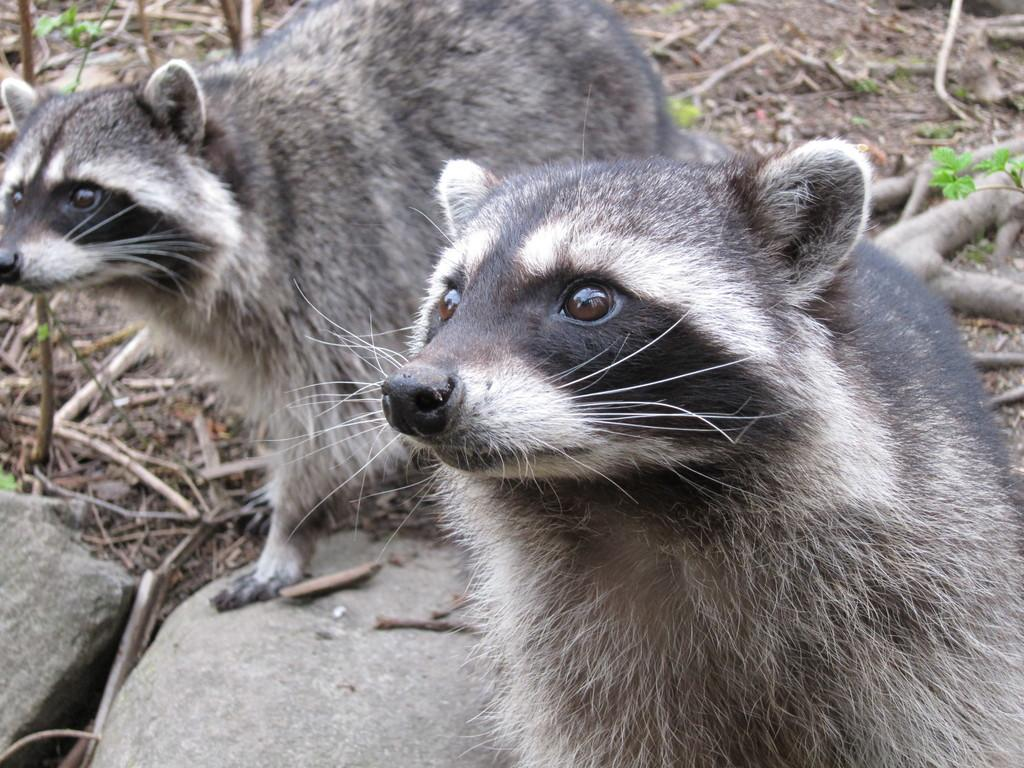How many animals can be seen in the image? There are two animals in the image. What else is present in the image besides the animals? Rocks, dried stems, dried leaves, and plants on the ground are visible in the image. Can you describe the plants in the image? The plants on the ground are visible among the rocks and dried stems. What is the distance between the animals and the farm in the image? There is no farm present in the image, so it is not possible to determine the distance between the animals and a farm. 